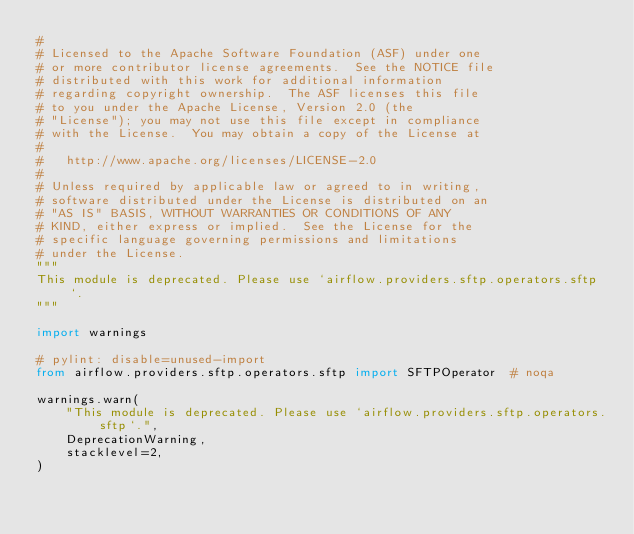<code> <loc_0><loc_0><loc_500><loc_500><_Python_>#
# Licensed to the Apache Software Foundation (ASF) under one
# or more contributor license agreements.  See the NOTICE file
# distributed with this work for additional information
# regarding copyright ownership.  The ASF licenses this file
# to you under the Apache License, Version 2.0 (the
# "License"); you may not use this file except in compliance
# with the License.  You may obtain a copy of the License at
#
#   http://www.apache.org/licenses/LICENSE-2.0
#
# Unless required by applicable law or agreed to in writing,
# software distributed under the License is distributed on an
# "AS IS" BASIS, WITHOUT WARRANTIES OR CONDITIONS OF ANY
# KIND, either express or implied.  See the License for the
# specific language governing permissions and limitations
# under the License.
"""
This module is deprecated. Please use `airflow.providers.sftp.operators.sftp`.
"""

import warnings

# pylint: disable=unused-import
from airflow.providers.sftp.operators.sftp import SFTPOperator  # noqa

warnings.warn(
    "This module is deprecated. Please use `airflow.providers.sftp.operators.sftp`.",
    DeprecationWarning,
    stacklevel=2,
)
</code> 